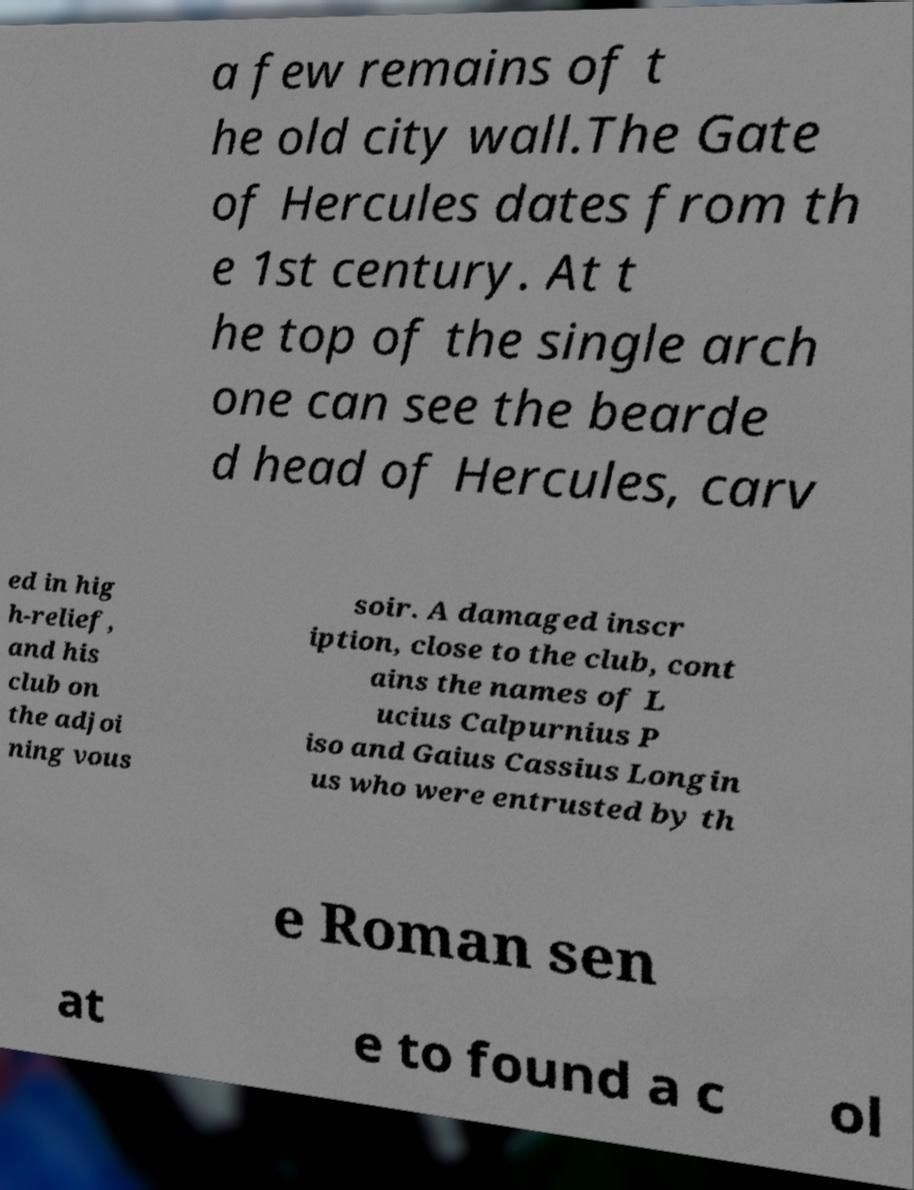I need the written content from this picture converted into text. Can you do that? a few remains of t he old city wall.The Gate of Hercules dates from th e 1st century. At t he top of the single arch one can see the bearde d head of Hercules, carv ed in hig h-relief, and his club on the adjoi ning vous soir. A damaged inscr iption, close to the club, cont ains the names of L ucius Calpurnius P iso and Gaius Cassius Longin us who were entrusted by th e Roman sen at e to found a c ol 